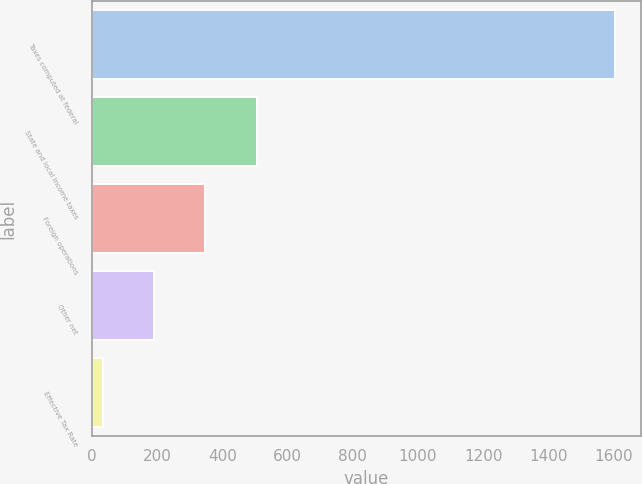Convert chart to OTSL. <chart><loc_0><loc_0><loc_500><loc_500><bar_chart><fcel>Taxes computed at federal<fcel>State and local income taxes<fcel>Foreign operations<fcel>Other net<fcel>Effective Tax Rate<nl><fcel>1603<fcel>505.12<fcel>348.28<fcel>191.44<fcel>34.6<nl></chart> 